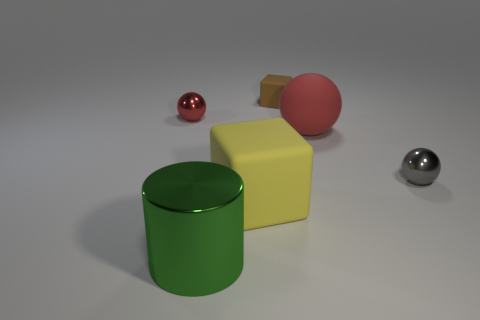Subtract all small shiny spheres. How many spheres are left? 1 Subtract all gray spheres. How many spheres are left? 2 Subtract all blocks. How many objects are left? 4 Add 1 small brown matte cubes. How many objects exist? 7 Add 5 big green cylinders. How many big green cylinders exist? 6 Subtract 2 red balls. How many objects are left? 4 Subtract 2 cubes. How many cubes are left? 0 Subtract all blue balls. Subtract all gray cylinders. How many balls are left? 3 Subtract all red blocks. How many green balls are left? 0 Subtract all big green metallic balls. Subtract all large red spheres. How many objects are left? 5 